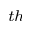<formula> <loc_0><loc_0><loc_500><loc_500>^ { t h }</formula> 